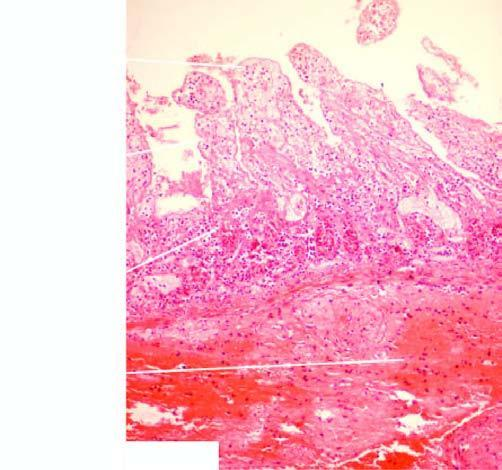s ziehl-neelsen also partly affected?
Answer the question using a single word or phrase. No 